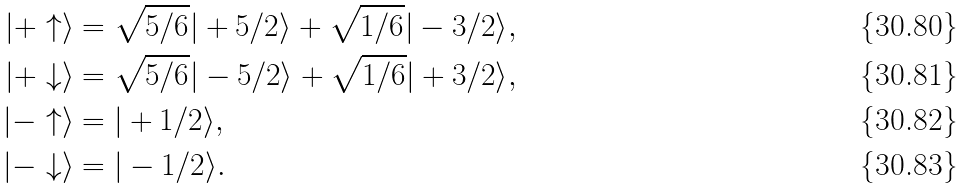<formula> <loc_0><loc_0><loc_500><loc_500>| + \uparrow \rangle & = \sqrt { 5 / 6 } | + 5 / 2 \rangle + \sqrt { 1 / 6 } | - 3 / 2 \rangle , \\ | + \downarrow \rangle & = \sqrt { 5 / 6 } | - 5 / 2 \rangle + \sqrt { 1 / 6 } | + 3 / 2 \rangle , \\ | - \uparrow \rangle & = | + 1 / 2 \rangle , \\ | - \downarrow \rangle & = | - 1 / 2 \rangle .</formula> 